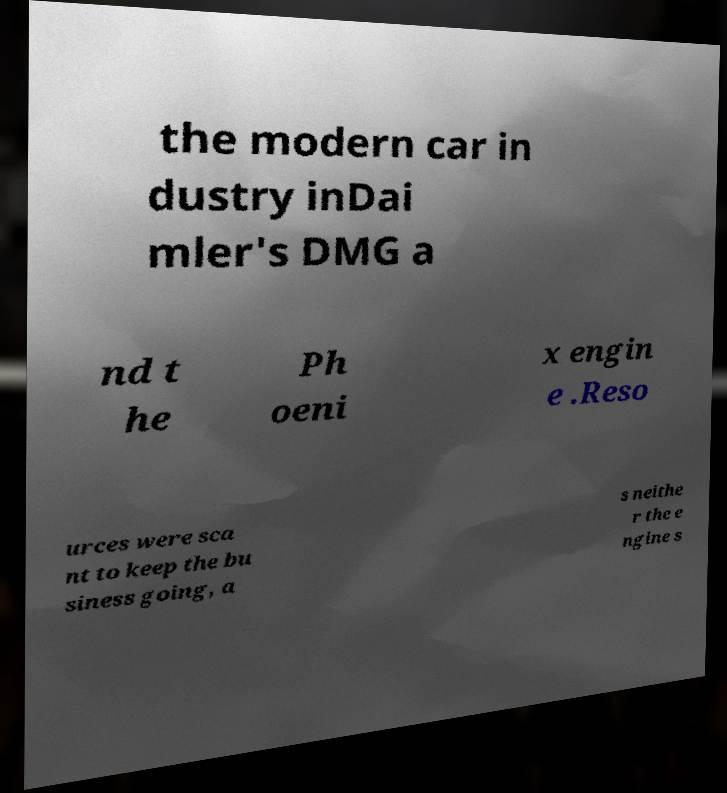Can you accurately transcribe the text from the provided image for me? the modern car in dustry inDai mler's DMG a nd t he Ph oeni x engin e .Reso urces were sca nt to keep the bu siness going, a s neithe r the e ngine s 